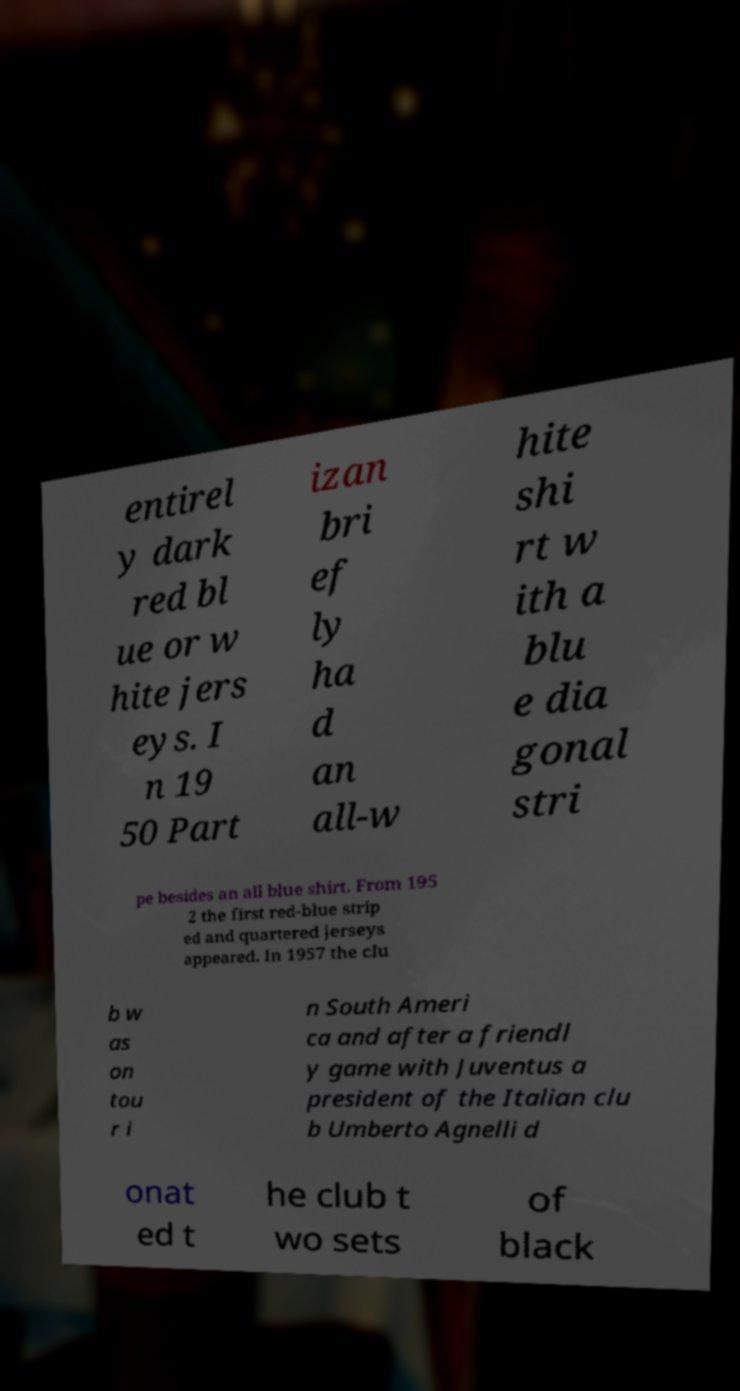Please identify and transcribe the text found in this image. entirel y dark red bl ue or w hite jers eys. I n 19 50 Part izan bri ef ly ha d an all-w hite shi rt w ith a blu e dia gonal stri pe besides an all blue shirt. From 195 2 the first red-blue strip ed and quartered jerseys appeared. In 1957 the clu b w as on tou r i n South Ameri ca and after a friendl y game with Juventus a president of the Italian clu b Umberto Agnelli d onat ed t he club t wo sets of black 